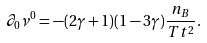<formula> <loc_0><loc_0><loc_500><loc_500>\partial _ { 0 } \nu ^ { 0 } = - ( 2 \gamma + 1 ) ( 1 - 3 \gamma ) \frac { n _ { B } } { T t ^ { 2 } } .</formula> 